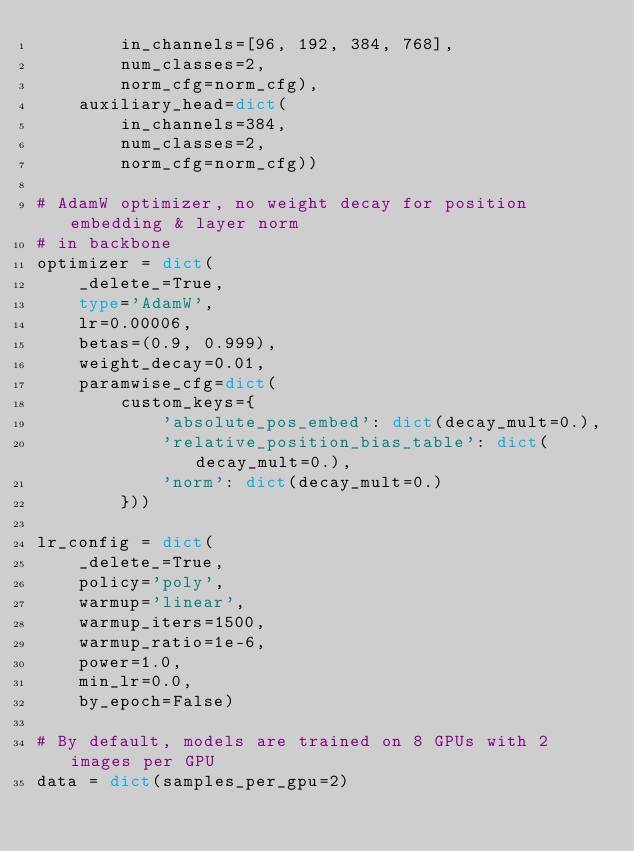<code> <loc_0><loc_0><loc_500><loc_500><_Python_>        in_channels=[96, 192, 384, 768],
        num_classes=2,
        norm_cfg=norm_cfg),
    auxiliary_head=dict(
        in_channels=384,
        num_classes=2,
        norm_cfg=norm_cfg))

# AdamW optimizer, no weight decay for position embedding & layer norm
# in backbone
optimizer = dict(
    _delete_=True,
    type='AdamW',
    lr=0.00006,
    betas=(0.9, 0.999),
    weight_decay=0.01,
    paramwise_cfg=dict(
        custom_keys={
            'absolute_pos_embed': dict(decay_mult=0.),
            'relative_position_bias_table': dict(decay_mult=0.),
            'norm': dict(decay_mult=0.)
        }))

lr_config = dict(
    _delete_=True,
    policy='poly',
    warmup='linear',
    warmup_iters=1500,
    warmup_ratio=1e-6,
    power=1.0,
    min_lr=0.0,
    by_epoch=False)

# By default, models are trained on 8 GPUs with 2 images per GPU
data = dict(samples_per_gpu=2)</code> 